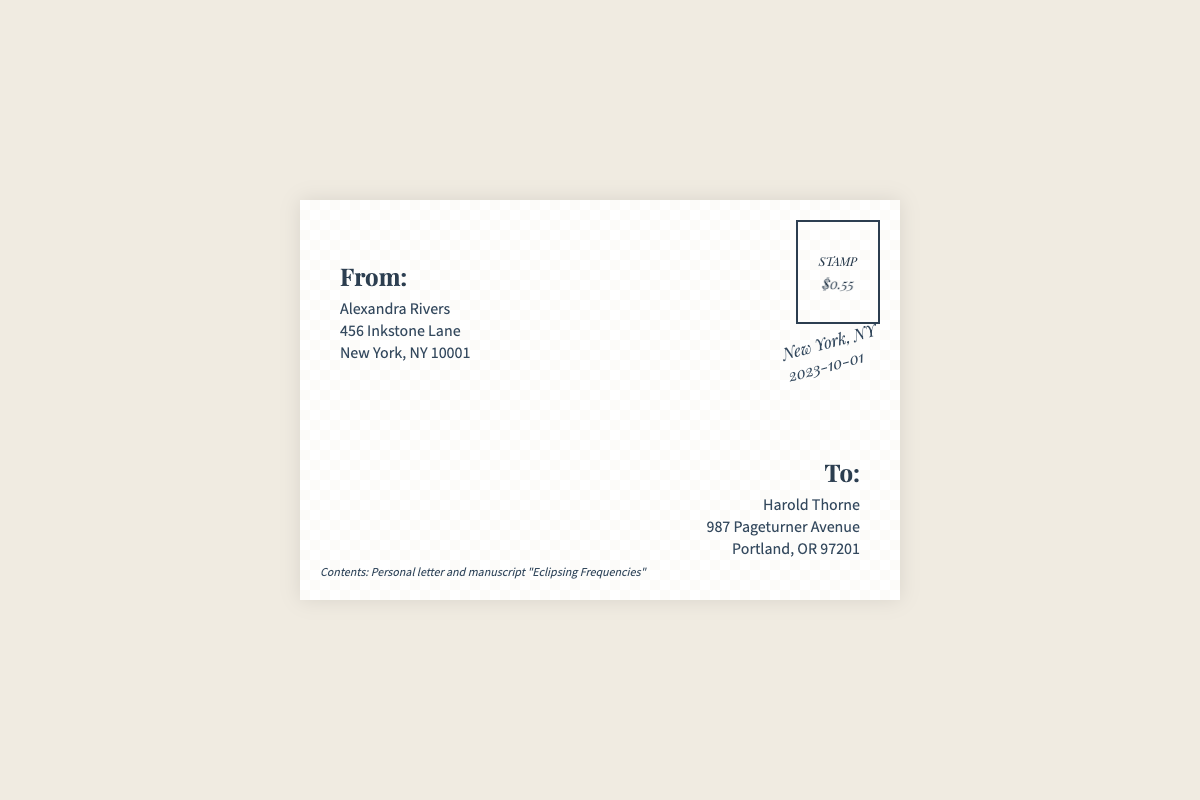what is the sender's name? The sender's name is listed prominently at the top left of the envelope.
Answer: Alexandra Rivers what is the recipient's address? The recipient's address is stated clearly at the bottom right of the envelope.
Answer: 987 Pageturner Avenue, Portland, OR 97201 what is the postmark date? The postmark date is indicated on the envelope near the stamp section.
Answer: 2023-10-01 what is the title of the manuscript? The title of the manuscript is provided in the contents section of the envelope.
Answer: Eclipsing Frequencies how many elements are listed in the contents? The contents section mentions two distinct items that are enclosed.
Answer: Personal letter and manuscript what city is the sender located in? The sender's location is revealed in the address at the top left of the envelope.
Answer: New York what is the cost on the stamp? The stamp's value is displayed in a bold format near the top right corner of the envelope.
Answer: $0.55 what style of font is used for the sender's information? The font style can be identified by observing the design of the sender's section.
Answer: Source Sans Pro what is the significance of the envelope's design? The design features a textured background that enhances the aesthetic appeal of the envelope.
Answer: Aesthetic enhancement 